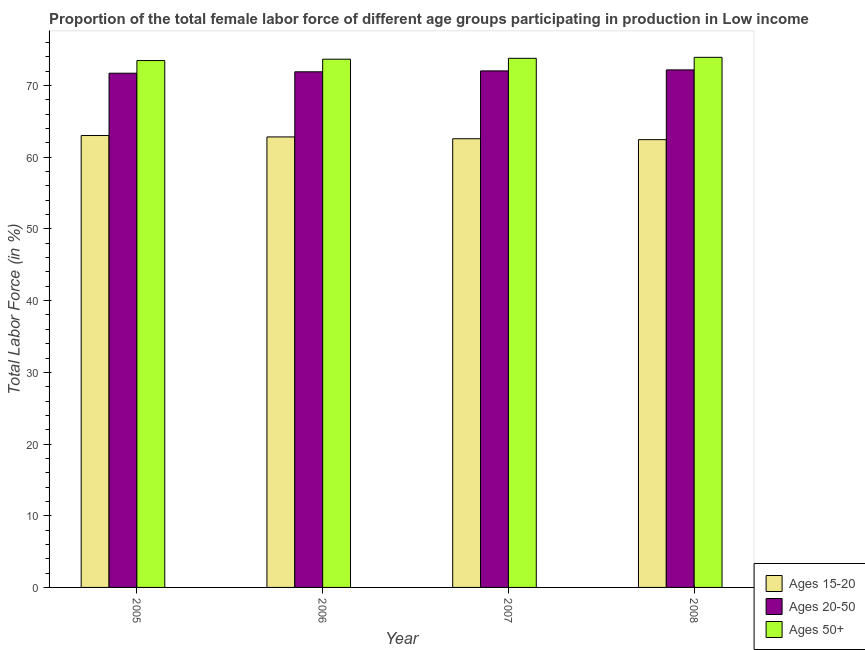How many groups of bars are there?
Offer a terse response. 4. Are the number of bars per tick equal to the number of legend labels?
Offer a terse response. Yes. Are the number of bars on each tick of the X-axis equal?
Offer a very short reply. Yes. In how many cases, is the number of bars for a given year not equal to the number of legend labels?
Provide a short and direct response. 0. What is the percentage of female labor force within the age group 20-50 in 2005?
Make the answer very short. 71.72. Across all years, what is the maximum percentage of female labor force above age 50?
Your answer should be very brief. 73.94. Across all years, what is the minimum percentage of female labor force above age 50?
Your answer should be very brief. 73.49. In which year was the percentage of female labor force within the age group 15-20 minimum?
Your answer should be compact. 2008. What is the total percentage of female labor force within the age group 20-50 in the graph?
Ensure brevity in your answer.  287.88. What is the difference between the percentage of female labor force above age 50 in 2005 and that in 2007?
Your answer should be very brief. -0.31. What is the difference between the percentage of female labor force above age 50 in 2007 and the percentage of female labor force within the age group 15-20 in 2005?
Your answer should be compact. 0.31. What is the average percentage of female labor force within the age group 15-20 per year?
Your response must be concise. 62.73. What is the ratio of the percentage of female labor force above age 50 in 2007 to that in 2008?
Your answer should be very brief. 1. Is the percentage of female labor force above age 50 in 2007 less than that in 2008?
Provide a succinct answer. Yes. Is the difference between the percentage of female labor force within the age group 20-50 in 2005 and 2007 greater than the difference between the percentage of female labor force within the age group 15-20 in 2005 and 2007?
Your response must be concise. No. What is the difference between the highest and the second highest percentage of female labor force within the age group 15-20?
Give a very brief answer. 0.2. What is the difference between the highest and the lowest percentage of female labor force above age 50?
Your answer should be very brief. 0.45. In how many years, is the percentage of female labor force within the age group 15-20 greater than the average percentage of female labor force within the age group 15-20 taken over all years?
Provide a short and direct response. 2. Is the sum of the percentage of female labor force above age 50 in 2005 and 2006 greater than the maximum percentage of female labor force within the age group 15-20 across all years?
Your response must be concise. Yes. What does the 3rd bar from the left in 2007 represents?
Ensure brevity in your answer.  Ages 50+. What does the 1st bar from the right in 2007 represents?
Ensure brevity in your answer.  Ages 50+. Is it the case that in every year, the sum of the percentage of female labor force within the age group 15-20 and percentage of female labor force within the age group 20-50 is greater than the percentage of female labor force above age 50?
Offer a very short reply. Yes. How many bars are there?
Your answer should be very brief. 12. Are the values on the major ticks of Y-axis written in scientific E-notation?
Your answer should be very brief. No. How many legend labels are there?
Keep it short and to the point. 3. What is the title of the graph?
Offer a terse response. Proportion of the total female labor force of different age groups participating in production in Low income. Does "Refusal of sex" appear as one of the legend labels in the graph?
Your response must be concise. No. What is the Total Labor Force (in %) in Ages 15-20 in 2005?
Your answer should be very brief. 63.03. What is the Total Labor Force (in %) in Ages 20-50 in 2005?
Keep it short and to the point. 71.72. What is the Total Labor Force (in %) of Ages 50+ in 2005?
Ensure brevity in your answer.  73.49. What is the Total Labor Force (in %) in Ages 15-20 in 2006?
Make the answer very short. 62.84. What is the Total Labor Force (in %) of Ages 20-50 in 2006?
Offer a terse response. 71.92. What is the Total Labor Force (in %) in Ages 50+ in 2006?
Offer a terse response. 73.68. What is the Total Labor Force (in %) in Ages 15-20 in 2007?
Your answer should be compact. 62.58. What is the Total Labor Force (in %) of Ages 20-50 in 2007?
Make the answer very short. 72.05. What is the Total Labor Force (in %) of Ages 50+ in 2007?
Offer a very short reply. 73.8. What is the Total Labor Force (in %) in Ages 15-20 in 2008?
Make the answer very short. 62.46. What is the Total Labor Force (in %) in Ages 20-50 in 2008?
Give a very brief answer. 72.19. What is the Total Labor Force (in %) of Ages 50+ in 2008?
Ensure brevity in your answer.  73.94. Across all years, what is the maximum Total Labor Force (in %) of Ages 15-20?
Keep it short and to the point. 63.03. Across all years, what is the maximum Total Labor Force (in %) of Ages 20-50?
Make the answer very short. 72.19. Across all years, what is the maximum Total Labor Force (in %) of Ages 50+?
Provide a short and direct response. 73.94. Across all years, what is the minimum Total Labor Force (in %) in Ages 15-20?
Offer a terse response. 62.46. Across all years, what is the minimum Total Labor Force (in %) in Ages 20-50?
Your answer should be compact. 71.72. Across all years, what is the minimum Total Labor Force (in %) of Ages 50+?
Your answer should be compact. 73.49. What is the total Total Labor Force (in %) of Ages 15-20 in the graph?
Provide a succinct answer. 250.91. What is the total Total Labor Force (in %) in Ages 20-50 in the graph?
Your answer should be compact. 287.88. What is the total Total Labor Force (in %) of Ages 50+ in the graph?
Ensure brevity in your answer.  294.91. What is the difference between the Total Labor Force (in %) of Ages 15-20 in 2005 and that in 2006?
Your response must be concise. 0.2. What is the difference between the Total Labor Force (in %) of Ages 20-50 in 2005 and that in 2006?
Offer a very short reply. -0.2. What is the difference between the Total Labor Force (in %) of Ages 50+ in 2005 and that in 2006?
Ensure brevity in your answer.  -0.19. What is the difference between the Total Labor Force (in %) in Ages 15-20 in 2005 and that in 2007?
Your answer should be compact. 0.45. What is the difference between the Total Labor Force (in %) of Ages 20-50 in 2005 and that in 2007?
Your response must be concise. -0.32. What is the difference between the Total Labor Force (in %) in Ages 50+ in 2005 and that in 2007?
Provide a succinct answer. -0.31. What is the difference between the Total Labor Force (in %) of Ages 15-20 in 2005 and that in 2008?
Your response must be concise. 0.58. What is the difference between the Total Labor Force (in %) of Ages 20-50 in 2005 and that in 2008?
Your answer should be compact. -0.46. What is the difference between the Total Labor Force (in %) of Ages 50+ in 2005 and that in 2008?
Make the answer very short. -0.45. What is the difference between the Total Labor Force (in %) of Ages 15-20 in 2006 and that in 2007?
Offer a very short reply. 0.25. What is the difference between the Total Labor Force (in %) of Ages 20-50 in 2006 and that in 2007?
Give a very brief answer. -0.13. What is the difference between the Total Labor Force (in %) of Ages 50+ in 2006 and that in 2007?
Offer a very short reply. -0.12. What is the difference between the Total Labor Force (in %) of Ages 15-20 in 2006 and that in 2008?
Offer a very short reply. 0.38. What is the difference between the Total Labor Force (in %) of Ages 20-50 in 2006 and that in 2008?
Give a very brief answer. -0.27. What is the difference between the Total Labor Force (in %) of Ages 50+ in 2006 and that in 2008?
Your answer should be very brief. -0.26. What is the difference between the Total Labor Force (in %) in Ages 15-20 in 2007 and that in 2008?
Your answer should be very brief. 0.12. What is the difference between the Total Labor Force (in %) in Ages 20-50 in 2007 and that in 2008?
Make the answer very short. -0.14. What is the difference between the Total Labor Force (in %) of Ages 50+ in 2007 and that in 2008?
Give a very brief answer. -0.14. What is the difference between the Total Labor Force (in %) of Ages 15-20 in 2005 and the Total Labor Force (in %) of Ages 20-50 in 2006?
Provide a short and direct response. -8.89. What is the difference between the Total Labor Force (in %) in Ages 15-20 in 2005 and the Total Labor Force (in %) in Ages 50+ in 2006?
Your answer should be compact. -10.65. What is the difference between the Total Labor Force (in %) of Ages 20-50 in 2005 and the Total Labor Force (in %) of Ages 50+ in 2006?
Provide a succinct answer. -1.95. What is the difference between the Total Labor Force (in %) of Ages 15-20 in 2005 and the Total Labor Force (in %) of Ages 20-50 in 2007?
Provide a succinct answer. -9.01. What is the difference between the Total Labor Force (in %) in Ages 15-20 in 2005 and the Total Labor Force (in %) in Ages 50+ in 2007?
Keep it short and to the point. -10.77. What is the difference between the Total Labor Force (in %) in Ages 20-50 in 2005 and the Total Labor Force (in %) in Ages 50+ in 2007?
Offer a very short reply. -2.08. What is the difference between the Total Labor Force (in %) in Ages 15-20 in 2005 and the Total Labor Force (in %) in Ages 20-50 in 2008?
Provide a short and direct response. -9.15. What is the difference between the Total Labor Force (in %) in Ages 15-20 in 2005 and the Total Labor Force (in %) in Ages 50+ in 2008?
Offer a very short reply. -10.91. What is the difference between the Total Labor Force (in %) of Ages 20-50 in 2005 and the Total Labor Force (in %) of Ages 50+ in 2008?
Ensure brevity in your answer.  -2.21. What is the difference between the Total Labor Force (in %) of Ages 15-20 in 2006 and the Total Labor Force (in %) of Ages 20-50 in 2007?
Provide a short and direct response. -9.21. What is the difference between the Total Labor Force (in %) of Ages 15-20 in 2006 and the Total Labor Force (in %) of Ages 50+ in 2007?
Keep it short and to the point. -10.96. What is the difference between the Total Labor Force (in %) of Ages 20-50 in 2006 and the Total Labor Force (in %) of Ages 50+ in 2007?
Provide a short and direct response. -1.88. What is the difference between the Total Labor Force (in %) in Ages 15-20 in 2006 and the Total Labor Force (in %) in Ages 20-50 in 2008?
Give a very brief answer. -9.35. What is the difference between the Total Labor Force (in %) of Ages 15-20 in 2006 and the Total Labor Force (in %) of Ages 50+ in 2008?
Offer a terse response. -11.1. What is the difference between the Total Labor Force (in %) of Ages 20-50 in 2006 and the Total Labor Force (in %) of Ages 50+ in 2008?
Offer a terse response. -2.02. What is the difference between the Total Labor Force (in %) of Ages 15-20 in 2007 and the Total Labor Force (in %) of Ages 20-50 in 2008?
Offer a terse response. -9.6. What is the difference between the Total Labor Force (in %) of Ages 15-20 in 2007 and the Total Labor Force (in %) of Ages 50+ in 2008?
Your answer should be compact. -11.36. What is the difference between the Total Labor Force (in %) of Ages 20-50 in 2007 and the Total Labor Force (in %) of Ages 50+ in 2008?
Provide a succinct answer. -1.89. What is the average Total Labor Force (in %) in Ages 15-20 per year?
Offer a terse response. 62.73. What is the average Total Labor Force (in %) in Ages 20-50 per year?
Keep it short and to the point. 71.97. What is the average Total Labor Force (in %) of Ages 50+ per year?
Keep it short and to the point. 73.73. In the year 2005, what is the difference between the Total Labor Force (in %) of Ages 15-20 and Total Labor Force (in %) of Ages 20-50?
Ensure brevity in your answer.  -8.69. In the year 2005, what is the difference between the Total Labor Force (in %) of Ages 15-20 and Total Labor Force (in %) of Ages 50+?
Offer a terse response. -10.46. In the year 2005, what is the difference between the Total Labor Force (in %) in Ages 20-50 and Total Labor Force (in %) in Ages 50+?
Offer a very short reply. -1.76. In the year 2006, what is the difference between the Total Labor Force (in %) in Ages 15-20 and Total Labor Force (in %) in Ages 20-50?
Offer a terse response. -9.09. In the year 2006, what is the difference between the Total Labor Force (in %) of Ages 15-20 and Total Labor Force (in %) of Ages 50+?
Ensure brevity in your answer.  -10.84. In the year 2006, what is the difference between the Total Labor Force (in %) of Ages 20-50 and Total Labor Force (in %) of Ages 50+?
Your response must be concise. -1.76. In the year 2007, what is the difference between the Total Labor Force (in %) in Ages 15-20 and Total Labor Force (in %) in Ages 20-50?
Offer a very short reply. -9.46. In the year 2007, what is the difference between the Total Labor Force (in %) of Ages 15-20 and Total Labor Force (in %) of Ages 50+?
Offer a terse response. -11.22. In the year 2007, what is the difference between the Total Labor Force (in %) of Ages 20-50 and Total Labor Force (in %) of Ages 50+?
Offer a terse response. -1.75. In the year 2008, what is the difference between the Total Labor Force (in %) of Ages 15-20 and Total Labor Force (in %) of Ages 20-50?
Keep it short and to the point. -9.73. In the year 2008, what is the difference between the Total Labor Force (in %) of Ages 15-20 and Total Labor Force (in %) of Ages 50+?
Ensure brevity in your answer.  -11.48. In the year 2008, what is the difference between the Total Labor Force (in %) of Ages 20-50 and Total Labor Force (in %) of Ages 50+?
Provide a succinct answer. -1.75. What is the ratio of the Total Labor Force (in %) of Ages 20-50 in 2005 to that in 2006?
Your answer should be very brief. 1. What is the ratio of the Total Labor Force (in %) of Ages 50+ in 2005 to that in 2006?
Make the answer very short. 1. What is the ratio of the Total Labor Force (in %) of Ages 15-20 in 2005 to that in 2007?
Provide a short and direct response. 1.01. What is the ratio of the Total Labor Force (in %) of Ages 20-50 in 2005 to that in 2007?
Your response must be concise. 1. What is the ratio of the Total Labor Force (in %) of Ages 15-20 in 2005 to that in 2008?
Provide a short and direct response. 1.01. What is the ratio of the Total Labor Force (in %) in Ages 20-50 in 2006 to that in 2007?
Give a very brief answer. 1. What is the ratio of the Total Labor Force (in %) of Ages 50+ in 2006 to that in 2007?
Ensure brevity in your answer.  1. What is the ratio of the Total Labor Force (in %) of Ages 20-50 in 2006 to that in 2008?
Provide a succinct answer. 1. What is the ratio of the Total Labor Force (in %) in Ages 50+ in 2006 to that in 2008?
Your answer should be compact. 1. What is the ratio of the Total Labor Force (in %) in Ages 15-20 in 2007 to that in 2008?
Make the answer very short. 1. What is the ratio of the Total Labor Force (in %) in Ages 20-50 in 2007 to that in 2008?
Provide a succinct answer. 1. What is the difference between the highest and the second highest Total Labor Force (in %) in Ages 15-20?
Your answer should be very brief. 0.2. What is the difference between the highest and the second highest Total Labor Force (in %) of Ages 20-50?
Ensure brevity in your answer.  0.14. What is the difference between the highest and the second highest Total Labor Force (in %) in Ages 50+?
Offer a very short reply. 0.14. What is the difference between the highest and the lowest Total Labor Force (in %) of Ages 15-20?
Your response must be concise. 0.58. What is the difference between the highest and the lowest Total Labor Force (in %) in Ages 20-50?
Your response must be concise. 0.46. What is the difference between the highest and the lowest Total Labor Force (in %) of Ages 50+?
Give a very brief answer. 0.45. 